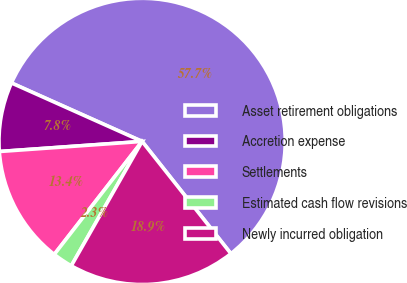<chart> <loc_0><loc_0><loc_500><loc_500><pie_chart><fcel>Asset retirement obligations<fcel>Accretion expense<fcel>Settlements<fcel>Estimated cash flow revisions<fcel>Newly incurred obligation<nl><fcel>57.65%<fcel>7.82%<fcel>13.36%<fcel>2.28%<fcel>18.89%<nl></chart> 